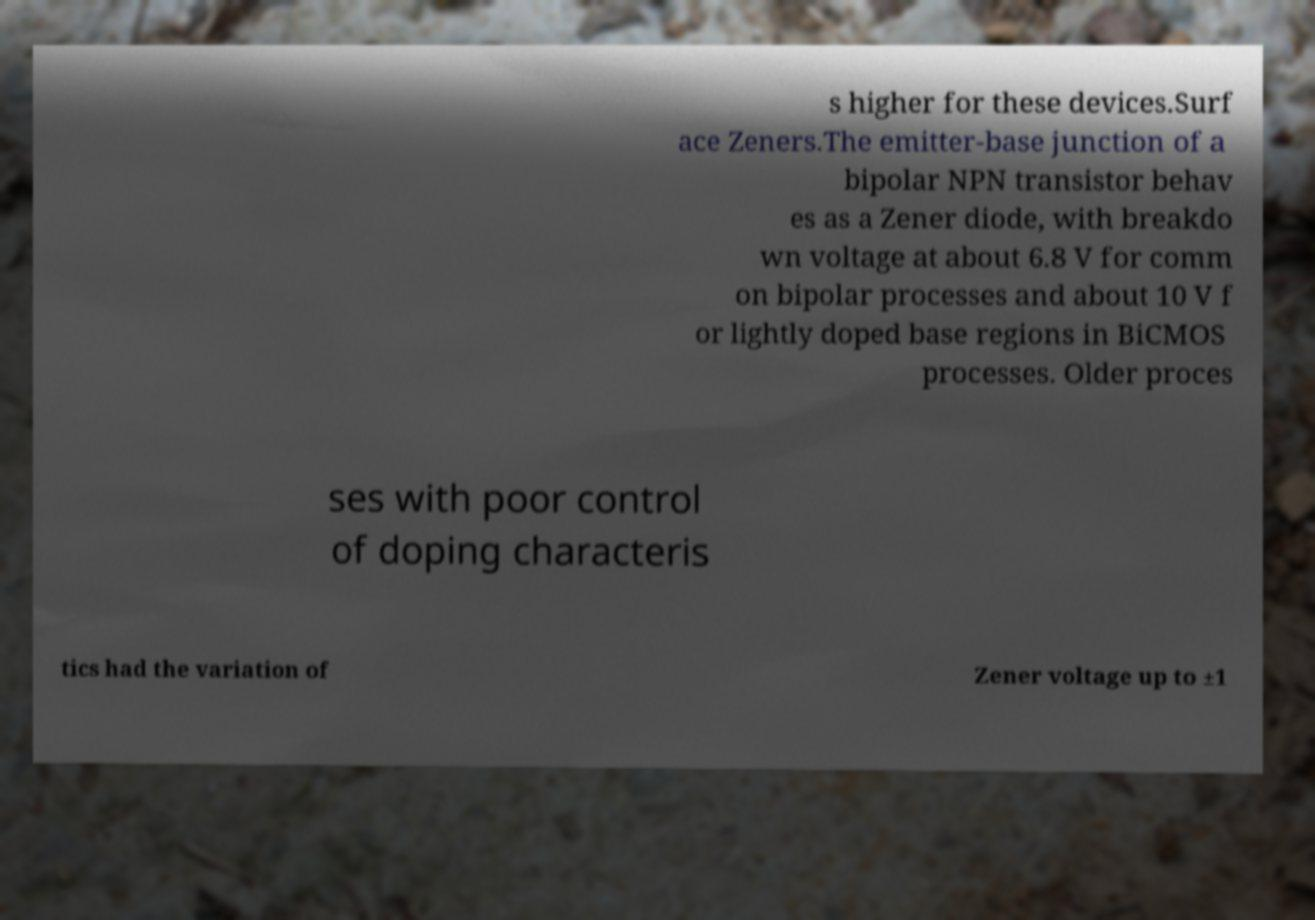Please read and relay the text visible in this image. What does it say? s higher for these devices.Surf ace Zeners.The emitter-base junction of a bipolar NPN transistor behav es as a Zener diode, with breakdo wn voltage at about 6.8 V for comm on bipolar processes and about 10 V f or lightly doped base regions in BiCMOS processes. Older proces ses with poor control of doping characteris tics had the variation of Zener voltage up to ±1 